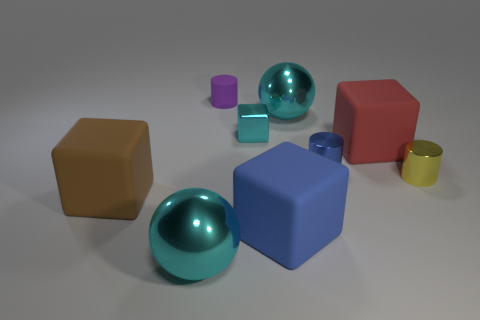Is the size of the blue cube the same as the cyan ball behind the big blue rubber object?
Offer a very short reply. Yes. There is a big blue object; what shape is it?
Your answer should be compact. Cube. How many tiny matte cylinders have the same color as the small block?
Ensure brevity in your answer.  0. The other tiny object that is the same shape as the red rubber thing is what color?
Provide a succinct answer. Cyan. What number of big blue rubber cubes are left of the small cylinder on the right side of the large red matte object?
Ensure brevity in your answer.  1. What number of cubes are big objects or big metallic things?
Give a very brief answer. 3. Are any rubber blocks visible?
Offer a terse response. Yes. What size is the yellow thing that is the same shape as the small purple matte thing?
Keep it short and to the point. Small. There is a big cyan object in front of the large shiny sphere right of the purple rubber cylinder; what shape is it?
Offer a terse response. Sphere. How many gray objects are either matte cubes or tiny shiny cylinders?
Keep it short and to the point. 0. 